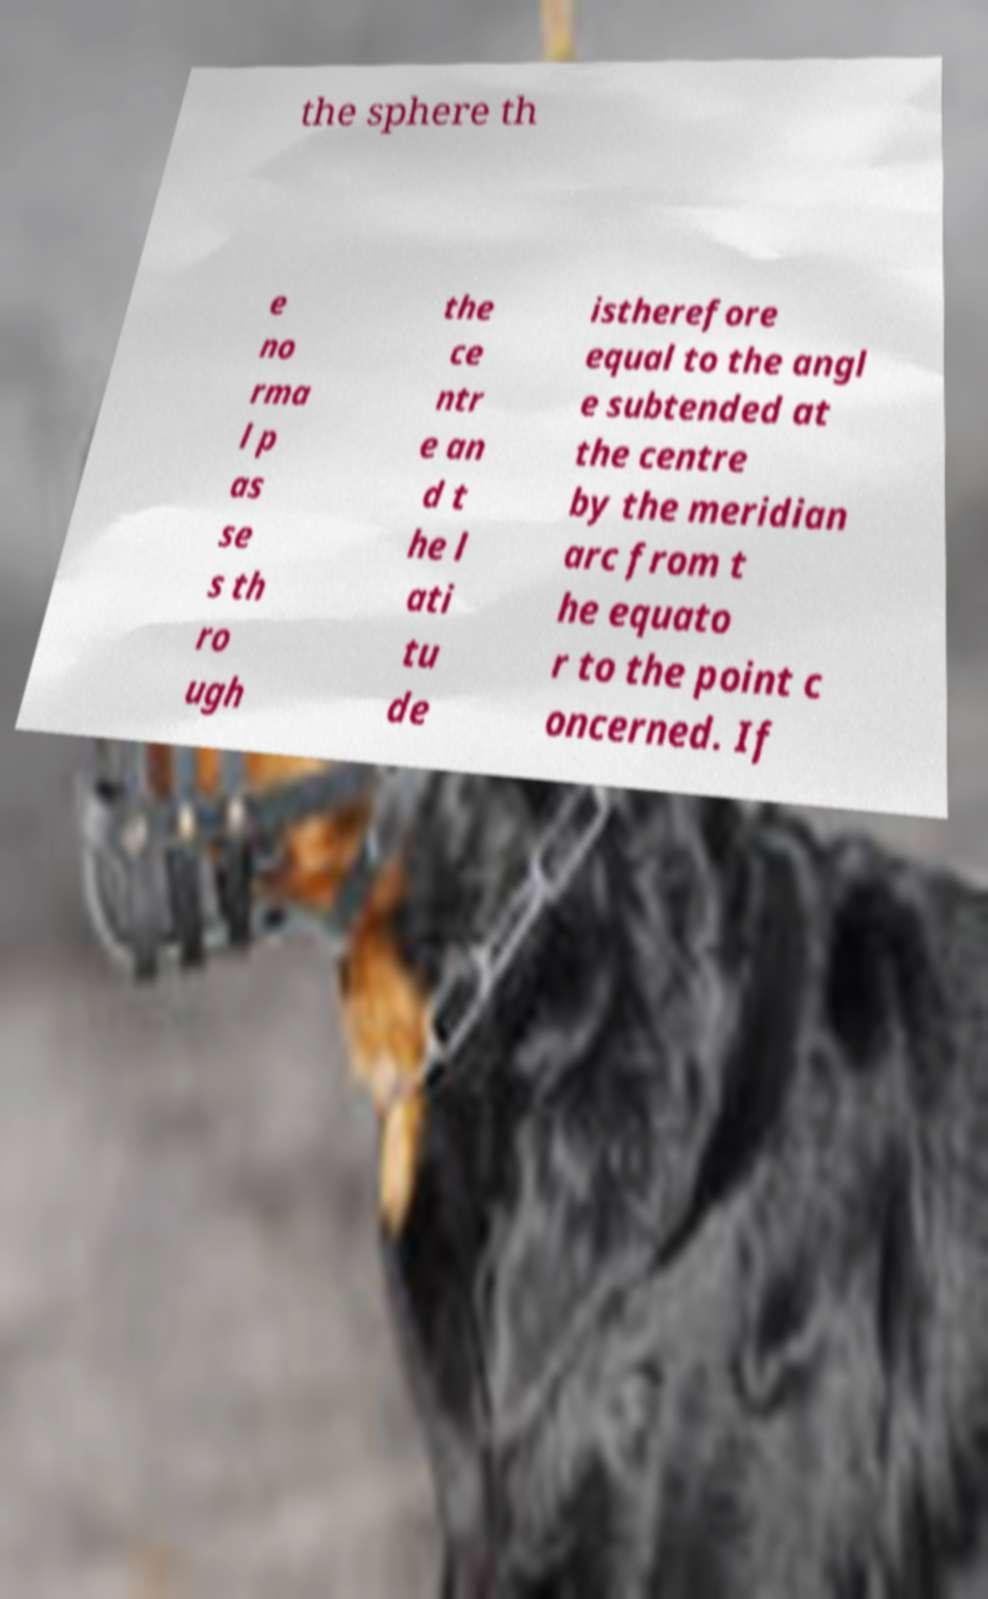Can you read and provide the text displayed in the image?This photo seems to have some interesting text. Can you extract and type it out for me? the sphere th e no rma l p as se s th ro ugh the ce ntr e an d t he l ati tu de istherefore equal to the angl e subtended at the centre by the meridian arc from t he equato r to the point c oncerned. If 